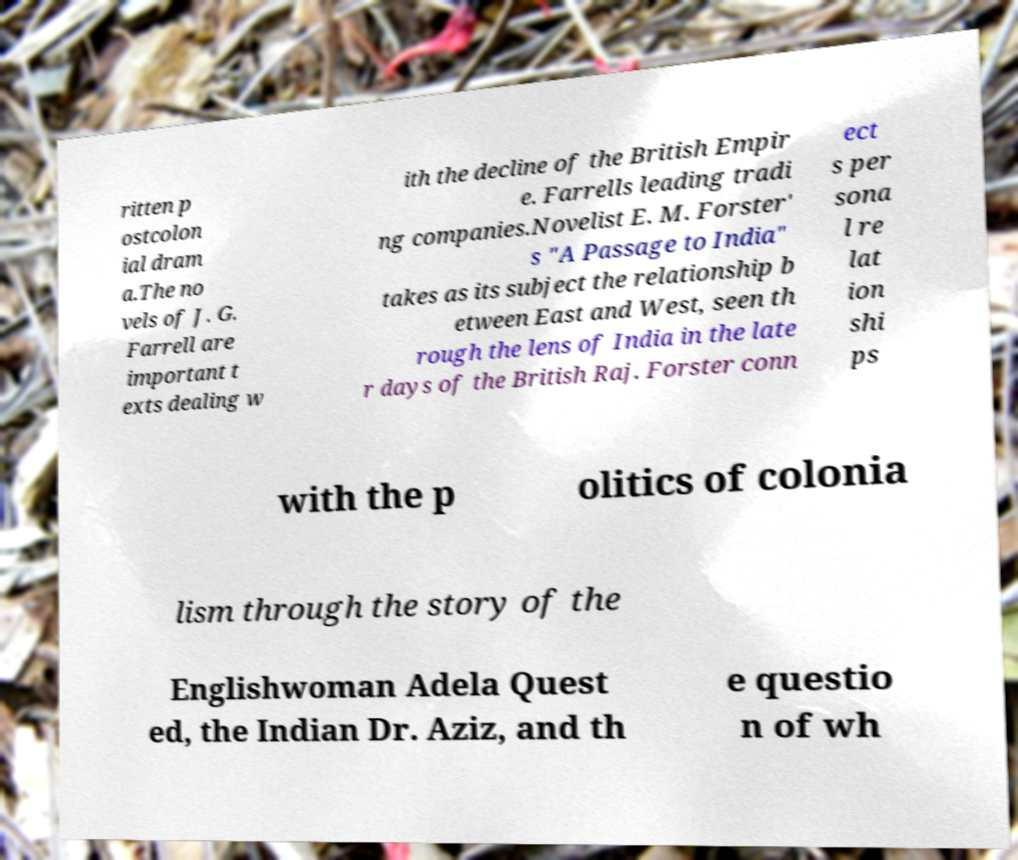Can you read and provide the text displayed in the image?This photo seems to have some interesting text. Can you extract and type it out for me? ritten p ostcolon ial dram a.The no vels of J. G. Farrell are important t exts dealing w ith the decline of the British Empir e. Farrells leading tradi ng companies.Novelist E. M. Forster' s "A Passage to India" takes as its subject the relationship b etween East and West, seen th rough the lens of India in the late r days of the British Raj. Forster conn ect s per sona l re lat ion shi ps with the p olitics of colonia lism through the story of the Englishwoman Adela Quest ed, the Indian Dr. Aziz, and th e questio n of wh 